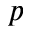Convert formula to latex. <formula><loc_0><loc_0><loc_500><loc_500>p</formula> 